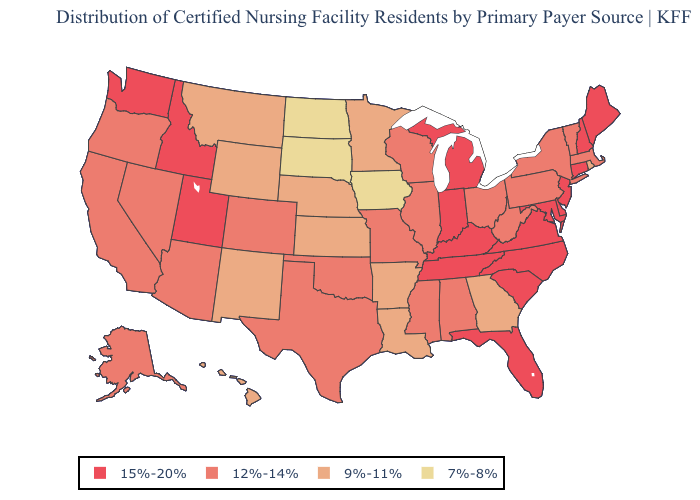Which states have the highest value in the USA?
Short answer required. Connecticut, Delaware, Florida, Idaho, Indiana, Kentucky, Maine, Maryland, Michigan, New Hampshire, New Jersey, North Carolina, South Carolina, Tennessee, Utah, Virginia, Washington. Does Florida have the highest value in the USA?
Be succinct. Yes. Does Vermont have a higher value than Kansas?
Give a very brief answer. Yes. Does Georgia have the lowest value in the South?
Short answer required. Yes. Does Massachusetts have the highest value in the Northeast?
Concise answer only. No. Does North Carolina have the same value as Florida?
Give a very brief answer. Yes. Does North Dakota have the lowest value in the USA?
Give a very brief answer. Yes. Name the states that have a value in the range 7%-8%?
Short answer required. Iowa, North Dakota, South Dakota. Which states have the lowest value in the MidWest?
Quick response, please. Iowa, North Dakota, South Dakota. What is the value of Louisiana?
Quick response, please. 9%-11%. What is the highest value in states that border Idaho?
Quick response, please. 15%-20%. What is the highest value in states that border Pennsylvania?
Keep it brief. 15%-20%. Name the states that have a value in the range 9%-11%?
Give a very brief answer. Arkansas, Georgia, Hawaii, Kansas, Louisiana, Minnesota, Montana, Nebraska, New Mexico, Rhode Island, Wyoming. Name the states that have a value in the range 15%-20%?
Be succinct. Connecticut, Delaware, Florida, Idaho, Indiana, Kentucky, Maine, Maryland, Michigan, New Hampshire, New Jersey, North Carolina, South Carolina, Tennessee, Utah, Virginia, Washington. Which states have the highest value in the USA?
Answer briefly. Connecticut, Delaware, Florida, Idaho, Indiana, Kentucky, Maine, Maryland, Michigan, New Hampshire, New Jersey, North Carolina, South Carolina, Tennessee, Utah, Virginia, Washington. 